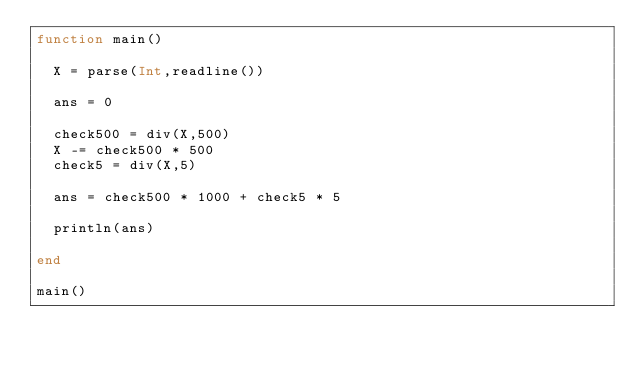Convert code to text. <code><loc_0><loc_0><loc_500><loc_500><_Julia_>function main()
  
  X = parse(Int,readline())
  
  ans = 0
  
  check500 = div(X,500)
  X -= check500 * 500
  check5 = div(X,5)
  
  ans = check500 * 1000 + check5 * 5
  
  println(ans)
  
end

main()</code> 